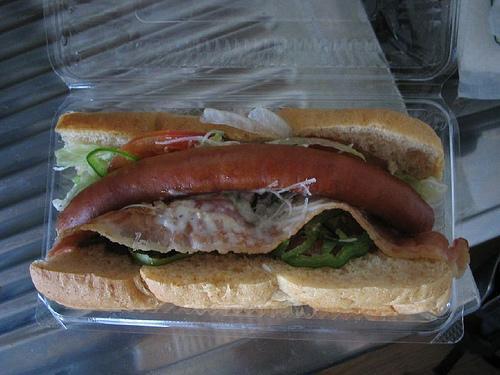How many people are holding a remote controller?
Give a very brief answer. 0. 